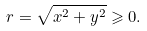<formula> <loc_0><loc_0><loc_500><loc_500>r = \sqrt { x ^ { 2 } + y ^ { 2 } } \geqslant 0 .</formula> 